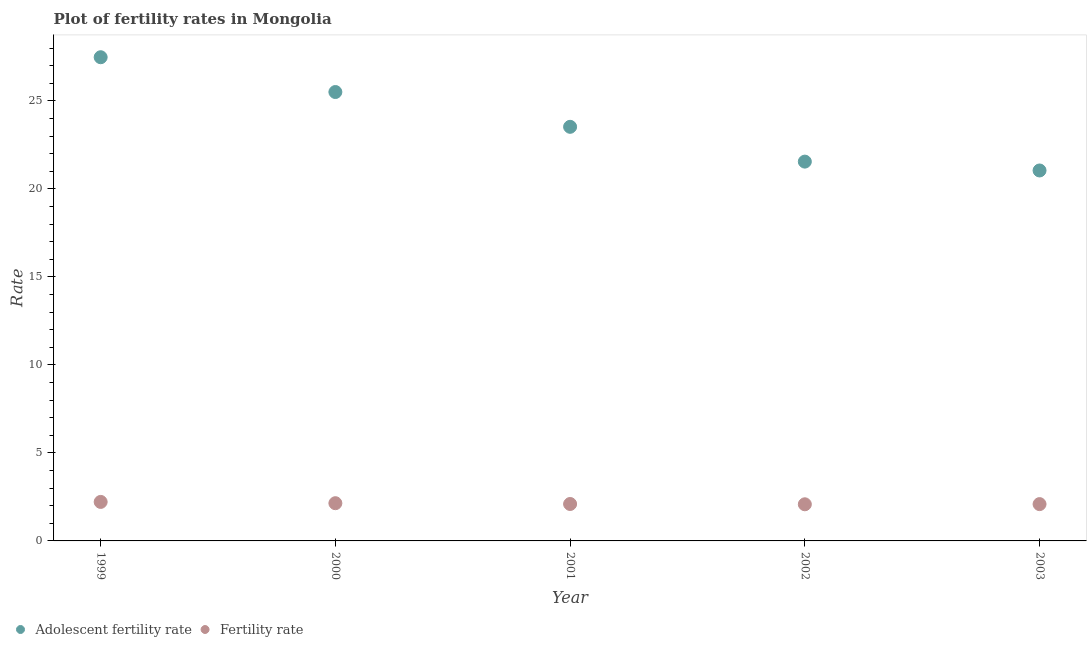How many different coloured dotlines are there?
Ensure brevity in your answer.  2. What is the adolescent fertility rate in 2003?
Your response must be concise. 21.04. Across all years, what is the maximum adolescent fertility rate?
Ensure brevity in your answer.  27.48. Across all years, what is the minimum fertility rate?
Give a very brief answer. 2.08. In which year was the fertility rate minimum?
Provide a succinct answer. 2002. What is the total fertility rate in the graph?
Your answer should be very brief. 10.63. What is the difference between the fertility rate in 1999 and that in 2003?
Your response must be concise. 0.12. What is the difference between the adolescent fertility rate in 2001 and the fertility rate in 1999?
Your answer should be very brief. 21.31. What is the average adolescent fertility rate per year?
Your answer should be very brief. 23.82. In the year 2000, what is the difference between the fertility rate and adolescent fertility rate?
Provide a short and direct response. -23.36. In how many years, is the fertility rate greater than 8?
Offer a terse response. 0. What is the ratio of the fertility rate in 2000 to that in 2001?
Your answer should be very brief. 1.02. Is the difference between the fertility rate in 1999 and 2001 greater than the difference between the adolescent fertility rate in 1999 and 2001?
Ensure brevity in your answer.  No. What is the difference between the highest and the second highest fertility rate?
Provide a succinct answer. 0.07. What is the difference between the highest and the lowest adolescent fertility rate?
Offer a terse response. 6.43. Is the sum of the adolescent fertility rate in 1999 and 2003 greater than the maximum fertility rate across all years?
Offer a terse response. Yes. Does the fertility rate monotonically increase over the years?
Give a very brief answer. No. Is the adolescent fertility rate strictly less than the fertility rate over the years?
Keep it short and to the point. No. Are the values on the major ticks of Y-axis written in scientific E-notation?
Ensure brevity in your answer.  No. Does the graph contain any zero values?
Make the answer very short. No. Does the graph contain grids?
Your answer should be compact. No. Where does the legend appear in the graph?
Provide a succinct answer. Bottom left. How many legend labels are there?
Give a very brief answer. 2. What is the title of the graph?
Give a very brief answer. Plot of fertility rates in Mongolia. Does "Death rate" appear as one of the legend labels in the graph?
Provide a short and direct response. No. What is the label or title of the X-axis?
Your answer should be very brief. Year. What is the label or title of the Y-axis?
Make the answer very short. Rate. What is the Rate of Adolescent fertility rate in 1999?
Your answer should be compact. 27.48. What is the Rate of Fertility rate in 1999?
Ensure brevity in your answer.  2.22. What is the Rate of Adolescent fertility rate in 2000?
Offer a terse response. 25.5. What is the Rate in Fertility rate in 2000?
Offer a very short reply. 2.14. What is the Rate of Adolescent fertility rate in 2001?
Provide a short and direct response. 23.52. What is the Rate of Fertility rate in 2001?
Provide a short and direct response. 2.1. What is the Rate of Adolescent fertility rate in 2002?
Your answer should be compact. 21.55. What is the Rate of Fertility rate in 2002?
Make the answer very short. 2.08. What is the Rate of Adolescent fertility rate in 2003?
Give a very brief answer. 21.04. What is the Rate of Fertility rate in 2003?
Your answer should be compact. 2.09. Across all years, what is the maximum Rate in Adolescent fertility rate?
Keep it short and to the point. 27.48. Across all years, what is the maximum Rate of Fertility rate?
Your answer should be compact. 2.22. Across all years, what is the minimum Rate of Adolescent fertility rate?
Offer a very short reply. 21.04. Across all years, what is the minimum Rate of Fertility rate?
Give a very brief answer. 2.08. What is the total Rate in Adolescent fertility rate in the graph?
Keep it short and to the point. 119.1. What is the total Rate in Fertility rate in the graph?
Keep it short and to the point. 10.63. What is the difference between the Rate in Adolescent fertility rate in 1999 and that in 2000?
Your answer should be compact. 1.98. What is the difference between the Rate of Fertility rate in 1999 and that in 2000?
Offer a very short reply. 0.07. What is the difference between the Rate of Adolescent fertility rate in 1999 and that in 2001?
Offer a terse response. 3.95. What is the difference between the Rate in Fertility rate in 1999 and that in 2001?
Provide a succinct answer. 0.12. What is the difference between the Rate of Adolescent fertility rate in 1999 and that in 2002?
Your response must be concise. 5.93. What is the difference between the Rate in Fertility rate in 1999 and that in 2002?
Offer a very short reply. 0.14. What is the difference between the Rate of Adolescent fertility rate in 1999 and that in 2003?
Provide a short and direct response. 6.43. What is the difference between the Rate of Fertility rate in 1999 and that in 2003?
Offer a very short reply. 0.12. What is the difference between the Rate in Adolescent fertility rate in 2000 and that in 2001?
Provide a succinct answer. 1.98. What is the difference between the Rate of Fertility rate in 2000 and that in 2001?
Provide a short and direct response. 0.04. What is the difference between the Rate of Adolescent fertility rate in 2000 and that in 2002?
Offer a very short reply. 3.95. What is the difference between the Rate in Fertility rate in 2000 and that in 2002?
Your answer should be very brief. 0.06. What is the difference between the Rate in Adolescent fertility rate in 2000 and that in 2003?
Provide a short and direct response. 4.46. What is the difference between the Rate of Fertility rate in 2000 and that in 2003?
Offer a very short reply. 0.05. What is the difference between the Rate of Adolescent fertility rate in 2001 and that in 2002?
Offer a terse response. 1.98. What is the difference between the Rate of Fertility rate in 2001 and that in 2002?
Your answer should be very brief. 0.02. What is the difference between the Rate in Adolescent fertility rate in 2001 and that in 2003?
Give a very brief answer. 2.48. What is the difference between the Rate in Fertility rate in 2001 and that in 2003?
Give a very brief answer. 0.01. What is the difference between the Rate in Adolescent fertility rate in 2002 and that in 2003?
Make the answer very short. 0.5. What is the difference between the Rate of Fertility rate in 2002 and that in 2003?
Give a very brief answer. -0.01. What is the difference between the Rate of Adolescent fertility rate in 1999 and the Rate of Fertility rate in 2000?
Your response must be concise. 25.34. What is the difference between the Rate of Adolescent fertility rate in 1999 and the Rate of Fertility rate in 2001?
Offer a very short reply. 25.38. What is the difference between the Rate of Adolescent fertility rate in 1999 and the Rate of Fertility rate in 2002?
Give a very brief answer. 25.4. What is the difference between the Rate in Adolescent fertility rate in 1999 and the Rate in Fertility rate in 2003?
Give a very brief answer. 25.39. What is the difference between the Rate of Adolescent fertility rate in 2000 and the Rate of Fertility rate in 2001?
Your answer should be compact. 23.4. What is the difference between the Rate of Adolescent fertility rate in 2000 and the Rate of Fertility rate in 2002?
Provide a succinct answer. 23.42. What is the difference between the Rate in Adolescent fertility rate in 2000 and the Rate in Fertility rate in 2003?
Your response must be concise. 23.41. What is the difference between the Rate in Adolescent fertility rate in 2001 and the Rate in Fertility rate in 2002?
Your answer should be compact. 21.44. What is the difference between the Rate in Adolescent fertility rate in 2001 and the Rate in Fertility rate in 2003?
Make the answer very short. 21.43. What is the difference between the Rate in Adolescent fertility rate in 2002 and the Rate in Fertility rate in 2003?
Ensure brevity in your answer.  19.46. What is the average Rate in Adolescent fertility rate per year?
Your answer should be compact. 23.82. What is the average Rate of Fertility rate per year?
Ensure brevity in your answer.  2.13. In the year 1999, what is the difference between the Rate of Adolescent fertility rate and Rate of Fertility rate?
Make the answer very short. 25.26. In the year 2000, what is the difference between the Rate in Adolescent fertility rate and Rate in Fertility rate?
Offer a very short reply. 23.36. In the year 2001, what is the difference between the Rate of Adolescent fertility rate and Rate of Fertility rate?
Give a very brief answer. 21.43. In the year 2002, what is the difference between the Rate in Adolescent fertility rate and Rate in Fertility rate?
Offer a very short reply. 19.47. In the year 2003, what is the difference between the Rate of Adolescent fertility rate and Rate of Fertility rate?
Make the answer very short. 18.95. What is the ratio of the Rate of Adolescent fertility rate in 1999 to that in 2000?
Your response must be concise. 1.08. What is the ratio of the Rate in Fertility rate in 1999 to that in 2000?
Your answer should be compact. 1.03. What is the ratio of the Rate of Adolescent fertility rate in 1999 to that in 2001?
Ensure brevity in your answer.  1.17. What is the ratio of the Rate in Fertility rate in 1999 to that in 2001?
Provide a short and direct response. 1.06. What is the ratio of the Rate in Adolescent fertility rate in 1999 to that in 2002?
Provide a succinct answer. 1.28. What is the ratio of the Rate in Fertility rate in 1999 to that in 2002?
Your answer should be very brief. 1.06. What is the ratio of the Rate in Adolescent fertility rate in 1999 to that in 2003?
Ensure brevity in your answer.  1.31. What is the ratio of the Rate of Fertility rate in 1999 to that in 2003?
Offer a terse response. 1.06. What is the ratio of the Rate of Adolescent fertility rate in 2000 to that in 2001?
Ensure brevity in your answer.  1.08. What is the ratio of the Rate of Fertility rate in 2000 to that in 2001?
Your response must be concise. 1.02. What is the ratio of the Rate in Adolescent fertility rate in 2000 to that in 2002?
Provide a succinct answer. 1.18. What is the ratio of the Rate of Fertility rate in 2000 to that in 2002?
Provide a short and direct response. 1.03. What is the ratio of the Rate of Adolescent fertility rate in 2000 to that in 2003?
Your answer should be very brief. 1.21. What is the ratio of the Rate in Fertility rate in 2000 to that in 2003?
Your answer should be compact. 1.02. What is the ratio of the Rate of Adolescent fertility rate in 2001 to that in 2002?
Keep it short and to the point. 1.09. What is the ratio of the Rate of Fertility rate in 2001 to that in 2002?
Ensure brevity in your answer.  1.01. What is the ratio of the Rate of Adolescent fertility rate in 2001 to that in 2003?
Offer a terse response. 1.12. What is the ratio of the Rate of Fertility rate in 2001 to that in 2003?
Your response must be concise. 1. What is the ratio of the Rate of Adolescent fertility rate in 2002 to that in 2003?
Your answer should be very brief. 1.02. What is the difference between the highest and the second highest Rate of Adolescent fertility rate?
Make the answer very short. 1.98. What is the difference between the highest and the second highest Rate of Fertility rate?
Your answer should be very brief. 0.07. What is the difference between the highest and the lowest Rate of Adolescent fertility rate?
Offer a terse response. 6.43. What is the difference between the highest and the lowest Rate in Fertility rate?
Your response must be concise. 0.14. 